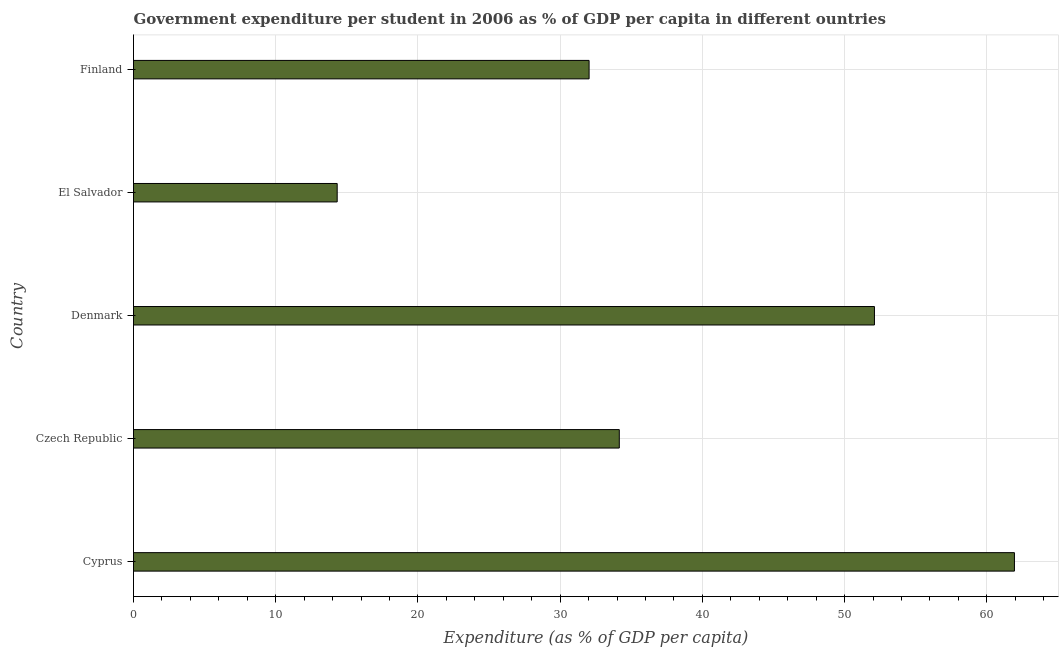Does the graph contain any zero values?
Your response must be concise. No. Does the graph contain grids?
Keep it short and to the point. Yes. What is the title of the graph?
Keep it short and to the point. Government expenditure per student in 2006 as % of GDP per capita in different ountries. What is the label or title of the X-axis?
Ensure brevity in your answer.  Expenditure (as % of GDP per capita). What is the government expenditure per student in Finland?
Offer a very short reply. 32.04. Across all countries, what is the maximum government expenditure per student?
Give a very brief answer. 61.95. Across all countries, what is the minimum government expenditure per student?
Ensure brevity in your answer.  14.32. In which country was the government expenditure per student maximum?
Your response must be concise. Cyprus. In which country was the government expenditure per student minimum?
Make the answer very short. El Salvador. What is the sum of the government expenditure per student?
Give a very brief answer. 194.57. What is the difference between the government expenditure per student in Cyprus and Czech Republic?
Make the answer very short. 27.79. What is the average government expenditure per student per country?
Provide a short and direct response. 38.91. What is the median government expenditure per student?
Offer a terse response. 34.16. In how many countries, is the government expenditure per student greater than 46 %?
Ensure brevity in your answer.  2. What is the ratio of the government expenditure per student in Denmark to that in Finland?
Keep it short and to the point. 1.63. What is the difference between the highest and the second highest government expenditure per student?
Make the answer very short. 9.84. What is the difference between the highest and the lowest government expenditure per student?
Offer a terse response. 47.62. What is the Expenditure (as % of GDP per capita) in Cyprus?
Offer a terse response. 61.95. What is the Expenditure (as % of GDP per capita) in Czech Republic?
Offer a terse response. 34.16. What is the Expenditure (as % of GDP per capita) of Denmark?
Ensure brevity in your answer.  52.1. What is the Expenditure (as % of GDP per capita) in El Salvador?
Make the answer very short. 14.32. What is the Expenditure (as % of GDP per capita) of Finland?
Your response must be concise. 32.04. What is the difference between the Expenditure (as % of GDP per capita) in Cyprus and Czech Republic?
Your answer should be compact. 27.79. What is the difference between the Expenditure (as % of GDP per capita) in Cyprus and Denmark?
Keep it short and to the point. 9.84. What is the difference between the Expenditure (as % of GDP per capita) in Cyprus and El Salvador?
Offer a very short reply. 47.62. What is the difference between the Expenditure (as % of GDP per capita) in Cyprus and Finland?
Your answer should be very brief. 29.91. What is the difference between the Expenditure (as % of GDP per capita) in Czech Republic and Denmark?
Offer a very short reply. -17.94. What is the difference between the Expenditure (as % of GDP per capita) in Czech Republic and El Salvador?
Provide a short and direct response. 19.84. What is the difference between the Expenditure (as % of GDP per capita) in Czech Republic and Finland?
Your answer should be compact. 2.12. What is the difference between the Expenditure (as % of GDP per capita) in Denmark and El Salvador?
Give a very brief answer. 37.78. What is the difference between the Expenditure (as % of GDP per capita) in Denmark and Finland?
Offer a terse response. 20.07. What is the difference between the Expenditure (as % of GDP per capita) in El Salvador and Finland?
Offer a terse response. -17.71. What is the ratio of the Expenditure (as % of GDP per capita) in Cyprus to that in Czech Republic?
Provide a succinct answer. 1.81. What is the ratio of the Expenditure (as % of GDP per capita) in Cyprus to that in Denmark?
Your answer should be compact. 1.19. What is the ratio of the Expenditure (as % of GDP per capita) in Cyprus to that in El Salvador?
Make the answer very short. 4.33. What is the ratio of the Expenditure (as % of GDP per capita) in Cyprus to that in Finland?
Your answer should be very brief. 1.93. What is the ratio of the Expenditure (as % of GDP per capita) in Czech Republic to that in Denmark?
Keep it short and to the point. 0.66. What is the ratio of the Expenditure (as % of GDP per capita) in Czech Republic to that in El Salvador?
Make the answer very short. 2.38. What is the ratio of the Expenditure (as % of GDP per capita) in Czech Republic to that in Finland?
Give a very brief answer. 1.07. What is the ratio of the Expenditure (as % of GDP per capita) in Denmark to that in El Salvador?
Make the answer very short. 3.64. What is the ratio of the Expenditure (as % of GDP per capita) in Denmark to that in Finland?
Make the answer very short. 1.63. What is the ratio of the Expenditure (as % of GDP per capita) in El Salvador to that in Finland?
Keep it short and to the point. 0.45. 